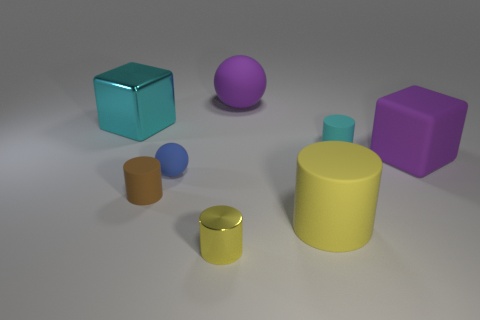Is there any other thing that is the same size as the brown cylinder? Yes, the purple sphere appears to be approximately the same size as the brown cylinder when considering their height and overall volume. 